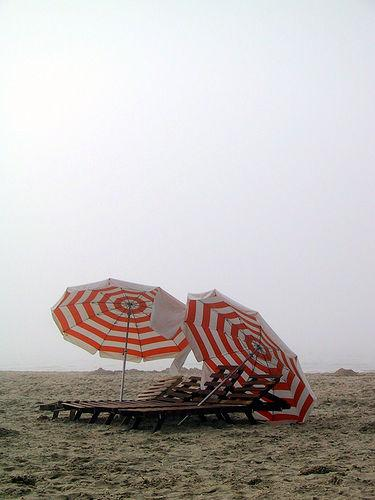What are the possible emotions evoked by the image? Possible emotions evoked by the image include relaxation, calmness, and perhaps a bit of gloominess due to the hazy skies. Identify three objects in the image and their colors. There is a brown chair, an umbrella with red and white stripes, and the sand is light tan in color. Analyze the object interaction in terms of arrangement and proximity. The chairs and umbrellas are arranged in close proximity on the beach. One of the umbrellas is leaning and touching the ground, while the chairs are leaning backwards or placed under the umbrellas for shade. Provide a brief description of the atmosphere and objects on the beach. The beach has a hazy atmosphere with four wooden lounge chairs, two large red and white striped umbrellas, and a mound of dirt in the distance. What type of weather is depicted in the image? The image shows light grey overcast skies, indicating a hazy or cloudy day. How is the overall quality of the image? Are the objects clearly visible? The image has a detailed description with defined object boundaries, which suggests that the overall quality is good and the objects are clearly visible. Describe the condition of the sand and its color. The sand appears to be brown and clumpy, with areas of dark grey trampled sand. Mention how many umbrellas, chairs, and stripes are in the image. There are two umbrellas, four chairs, and numerous stripes on the umbrellas. What are the umbrellas made of and what is their condition? The umbrellas have metal canopies, center posts, and red and white stripes. One umbrella is unsupported and lying in the sand. How many benches are under the umbrellas and what is their color? There are multiple benches under the umbrellas, and they are brown in color. 